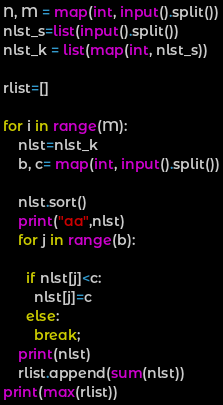Convert code to text. <code><loc_0><loc_0><loc_500><loc_500><_Python_>N, M = map(int, input().split())
nlst_s=list(input().split())
nlst_k = list(map(int, nlst_s))
 
rlist=[]
 
for i in range(M):
    nlst=nlst_k
    b, c= map(int, input().split())
    
    nlst.sort()
    print("aa",nlst)
    for j in range(b):
      
      if nlst[j]<c:
        nlst[j]=c
      else:
        break;
    print(nlst)
    rlist.append(sum(nlst))
print(max(rlist))</code> 